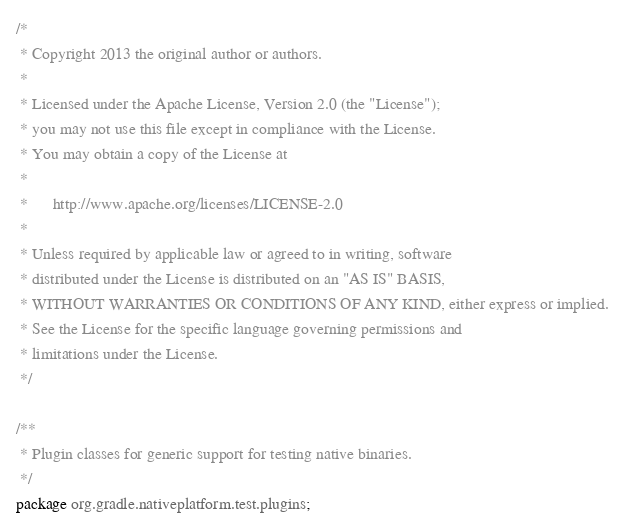Convert code to text. <code><loc_0><loc_0><loc_500><loc_500><_Java_>/*
 * Copyright 2013 the original author or authors.
 *
 * Licensed under the Apache License, Version 2.0 (the "License");
 * you may not use this file except in compliance with the License.
 * You may obtain a copy of the License at
 *
 *      http://www.apache.org/licenses/LICENSE-2.0
 *
 * Unless required by applicable law or agreed to in writing, software
 * distributed under the License is distributed on an "AS IS" BASIS,
 * WITHOUT WARRANTIES OR CONDITIONS OF ANY KIND, either express or implied.
 * See the License for the specific language governing permissions and
 * limitations under the License.
 */

/**
 * Plugin classes for generic support for testing native binaries.
 */
package org.gradle.nativeplatform.test.plugins;
</code> 